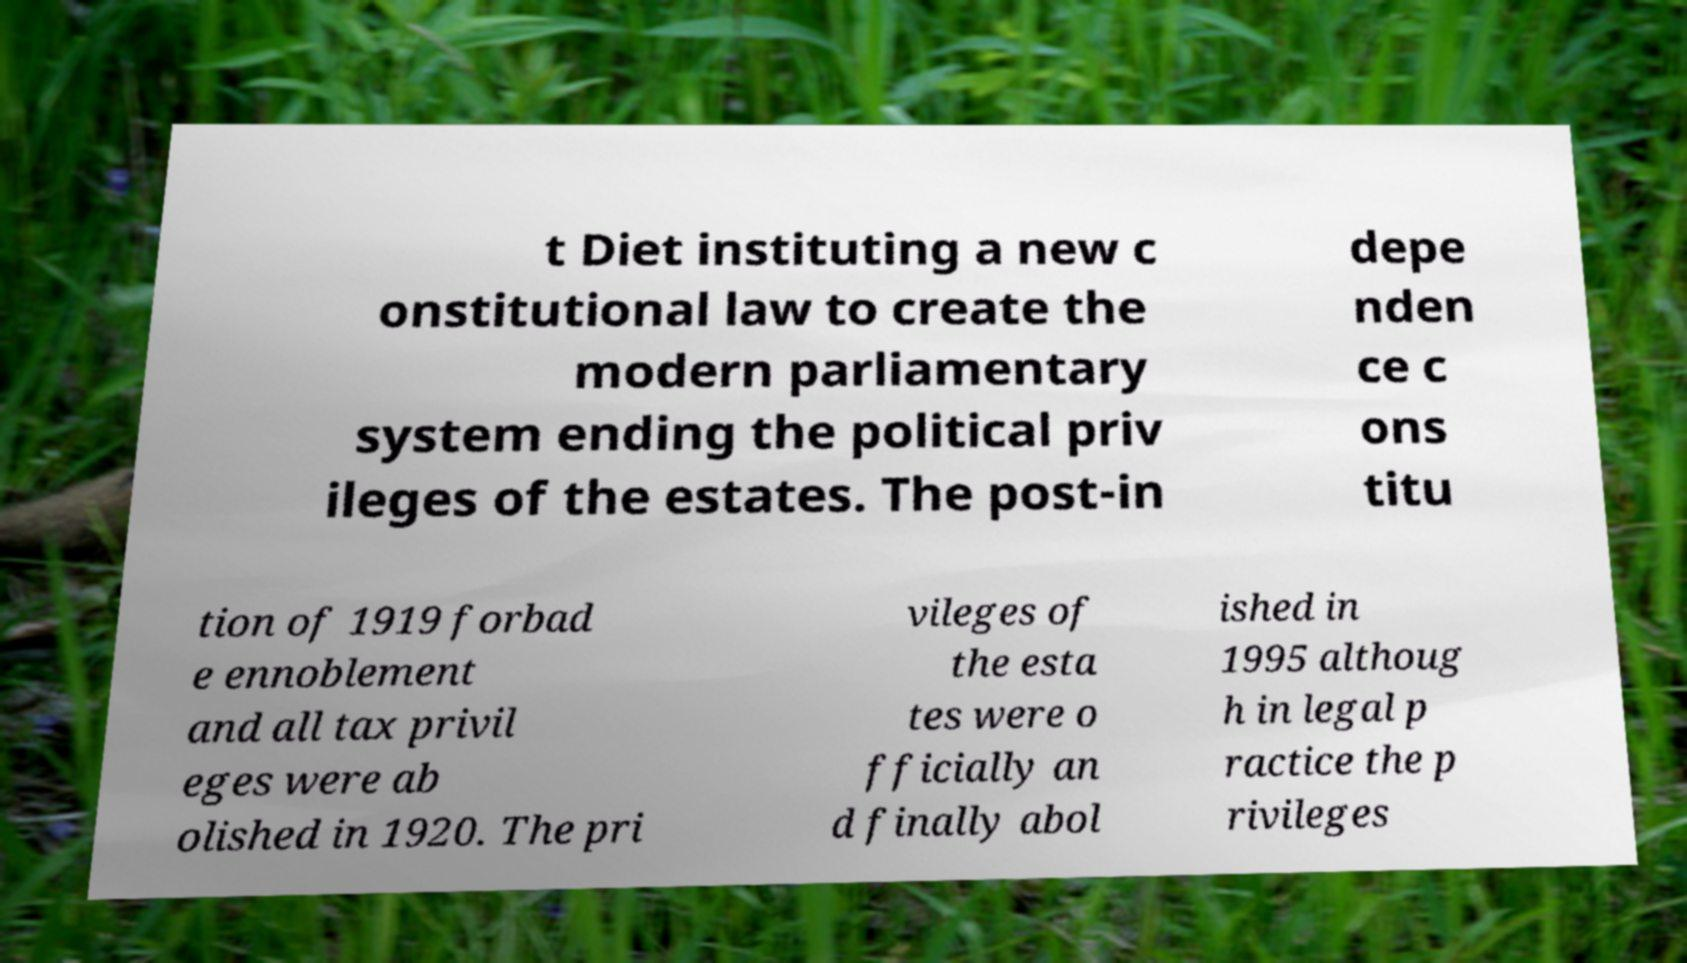What messages or text are displayed in this image? I need them in a readable, typed format. t Diet instituting a new c onstitutional law to create the modern parliamentary system ending the political priv ileges of the estates. The post-in depe nden ce c ons titu tion of 1919 forbad e ennoblement and all tax privil eges were ab olished in 1920. The pri vileges of the esta tes were o fficially an d finally abol ished in 1995 althoug h in legal p ractice the p rivileges 